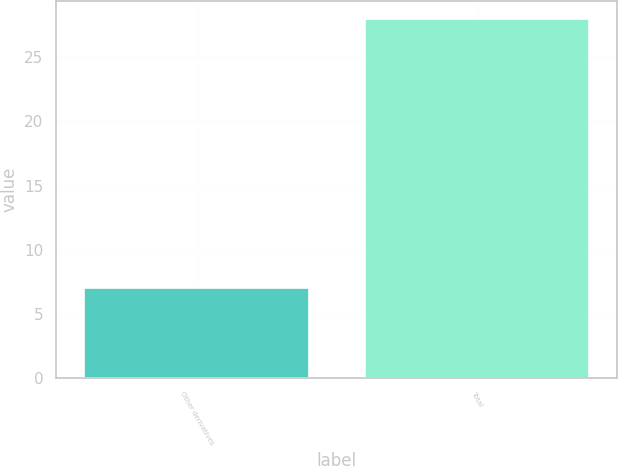<chart> <loc_0><loc_0><loc_500><loc_500><bar_chart><fcel>Other derivatives<fcel>Total<nl><fcel>7<fcel>28<nl></chart> 